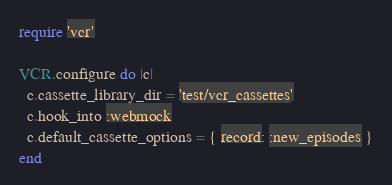Convert code to text. <code><loc_0><loc_0><loc_500><loc_500><_Ruby_>require 'vcr'

VCR.configure do |c|
  c.cassette_library_dir = 'test/vcr_cassettes'
  c.hook_into :webmock
  c.default_cassette_options = { record: :new_episodes }
end
</code> 